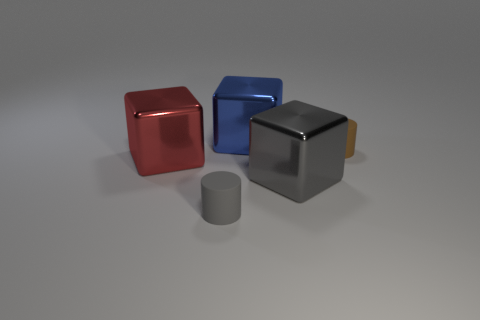Subtract all red metal cubes. How many cubes are left? 2 Subtract all red blocks. How many blocks are left? 2 Add 5 tiny rubber objects. How many objects exist? 10 Subtract 2 cylinders. How many cylinders are left? 0 Add 1 tiny gray matte objects. How many tiny gray matte objects are left? 2 Add 5 tiny brown objects. How many tiny brown objects exist? 6 Subtract 0 blue spheres. How many objects are left? 5 Subtract all blocks. How many objects are left? 2 Subtract all brown cylinders. Subtract all green balls. How many cylinders are left? 1 Subtract all cyan cylinders. How many gray cubes are left? 1 